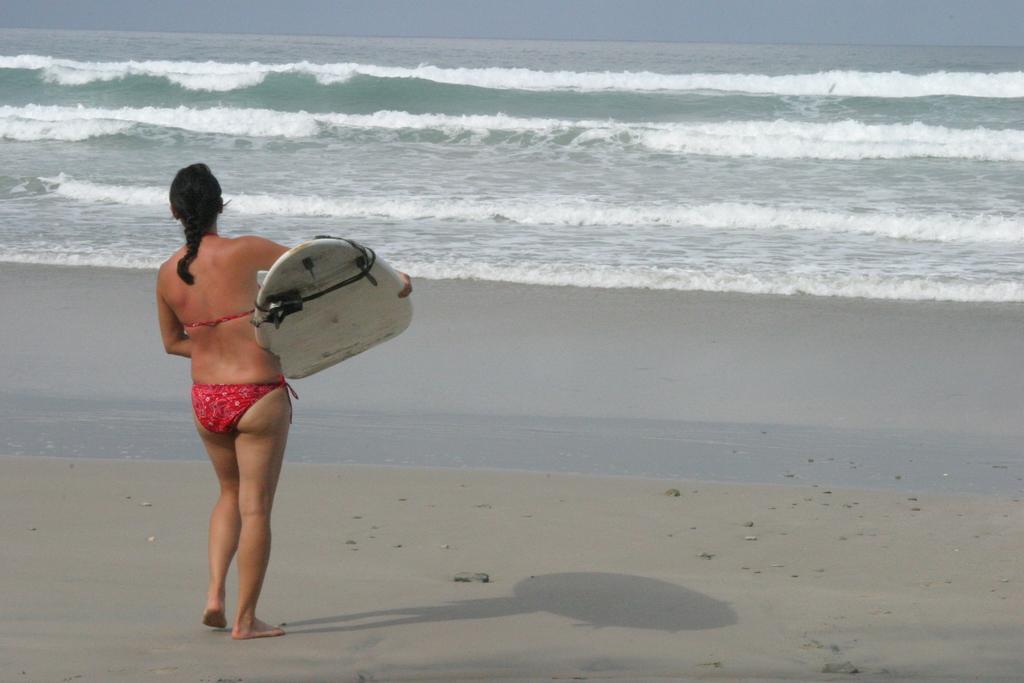Could you give a brief overview of what you see in this image? In this picture we can see a woman standing and holding a surfboard, in the background there is water. 